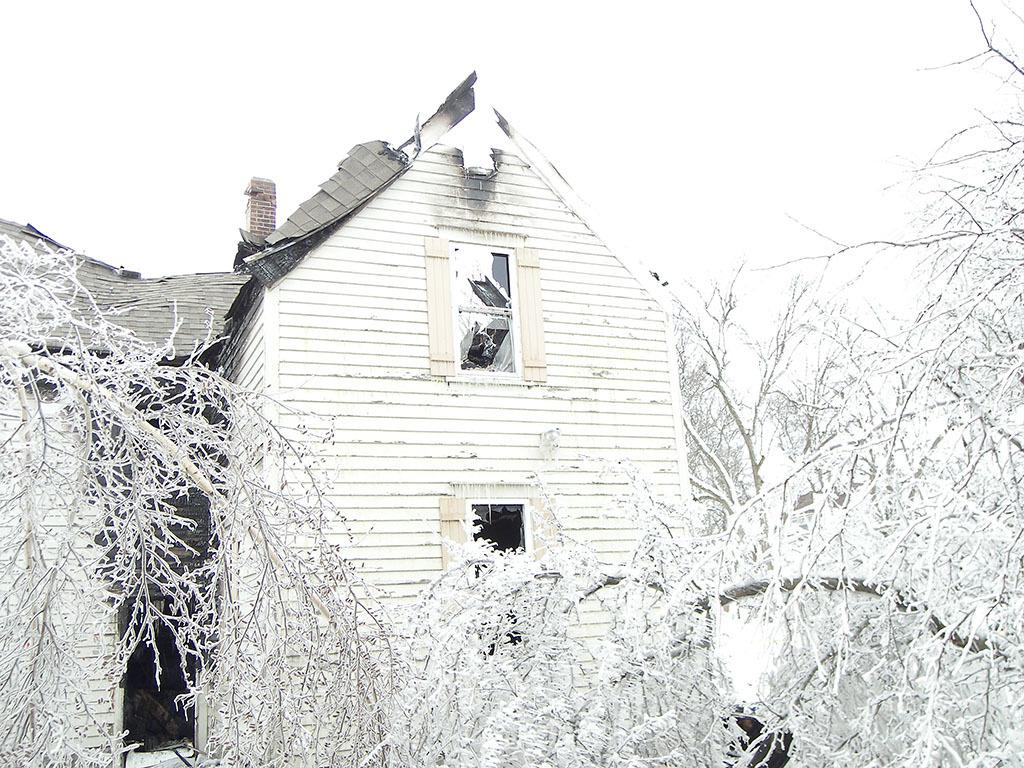What structure is located in the center of the image? There is a shed in the center of the image. What type of vegetation is at the bottom of the image? There are trees at the bottom of the image. What can be seen in the background of the image? The sky is visible in the background of the image. What type of force can be seen acting on the shed in the image? There is no force acting on the shed in the image; it appears to be stationary. Can you see any fangs or sharp teeth on the trees in the image? There are no fangs or sharp teeth present on the trees in the image; they are simply depicted as trees. 